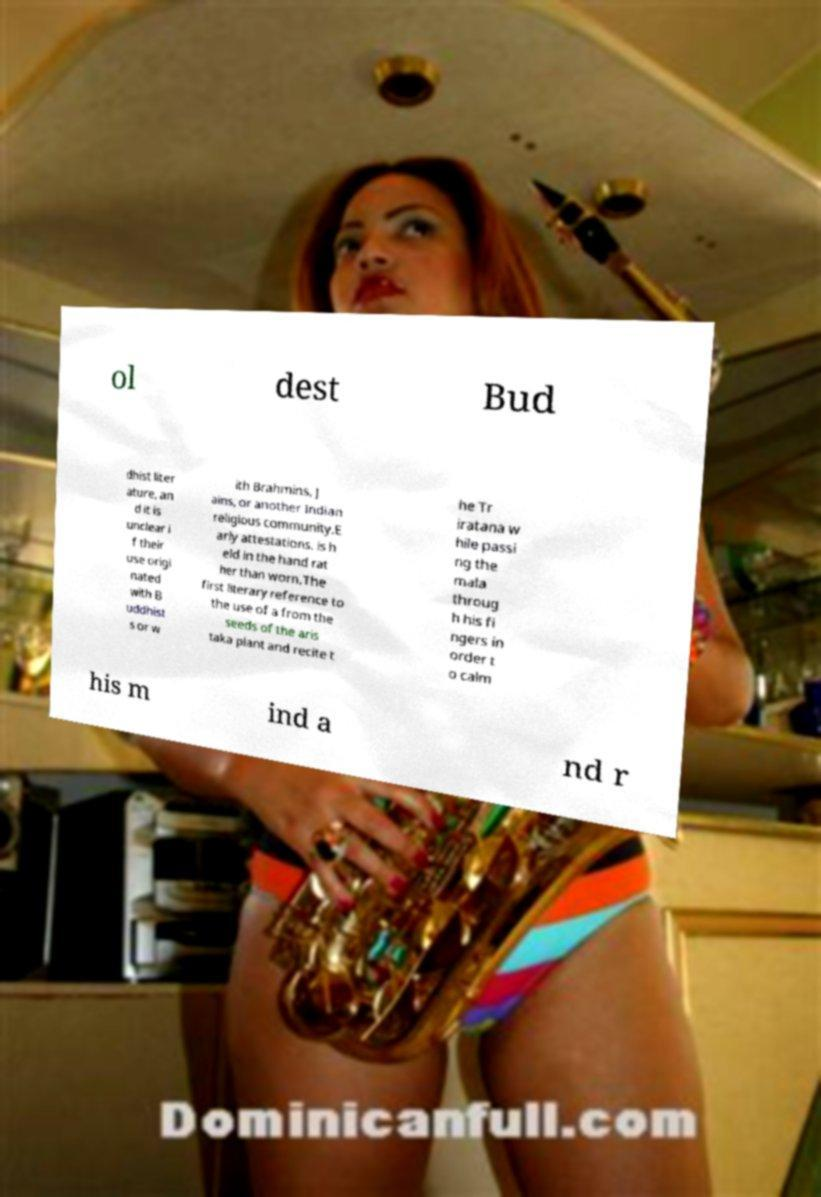For documentation purposes, I need the text within this image transcribed. Could you provide that? ol dest Bud dhist liter ature, an d it is unclear i f their use origi nated with B uddhist s or w ith Brahmins, J ains, or another Indian religious community.E arly attestations. is h eld in the hand rat her than worn.The first literary reference to the use of a from the seeds of the aris taka plant and recite t he Tr iratana w hile passi ng the mala throug h his fi ngers in order t o calm his m ind a nd r 